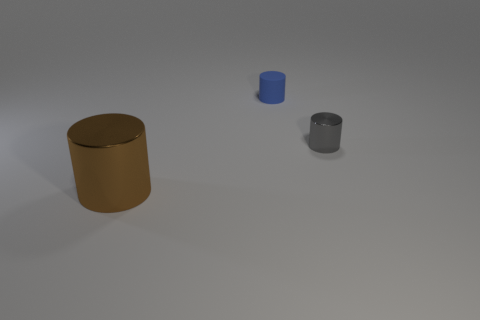There is a large metal cylinder in front of the small blue cylinder; what is its color?
Your answer should be very brief. Brown. Are there fewer large brown metallic cylinders on the left side of the tiny gray thing than brown matte objects?
Your response must be concise. No. Do the big thing and the blue cylinder have the same material?
Give a very brief answer. No. There is a blue object that is the same shape as the small gray object; what size is it?
Keep it short and to the point. Small. How many things are small objects that are behind the gray cylinder or cylinders that are in front of the tiny blue object?
Provide a succinct answer. 3. Are there fewer things than shiny things?
Your answer should be compact. No. There is a gray shiny object; does it have the same size as the shiny object that is on the left side of the blue matte cylinder?
Provide a short and direct response. No. How many matte things are large blue blocks or small cylinders?
Your answer should be compact. 1. Are there more big metal cylinders than cylinders?
Your answer should be compact. No. There is a tiny object that is behind the metallic thing that is behind the large metallic cylinder; what is its shape?
Your answer should be very brief. Cylinder. 